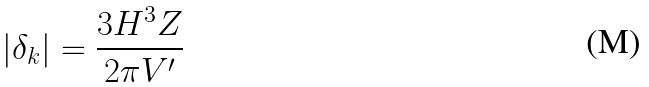Convert formula to latex. <formula><loc_0><loc_0><loc_500><loc_500>| \delta _ { k } | = \frac { 3 H ^ { 3 } Z } { 2 \pi V ^ { \prime } }</formula> 